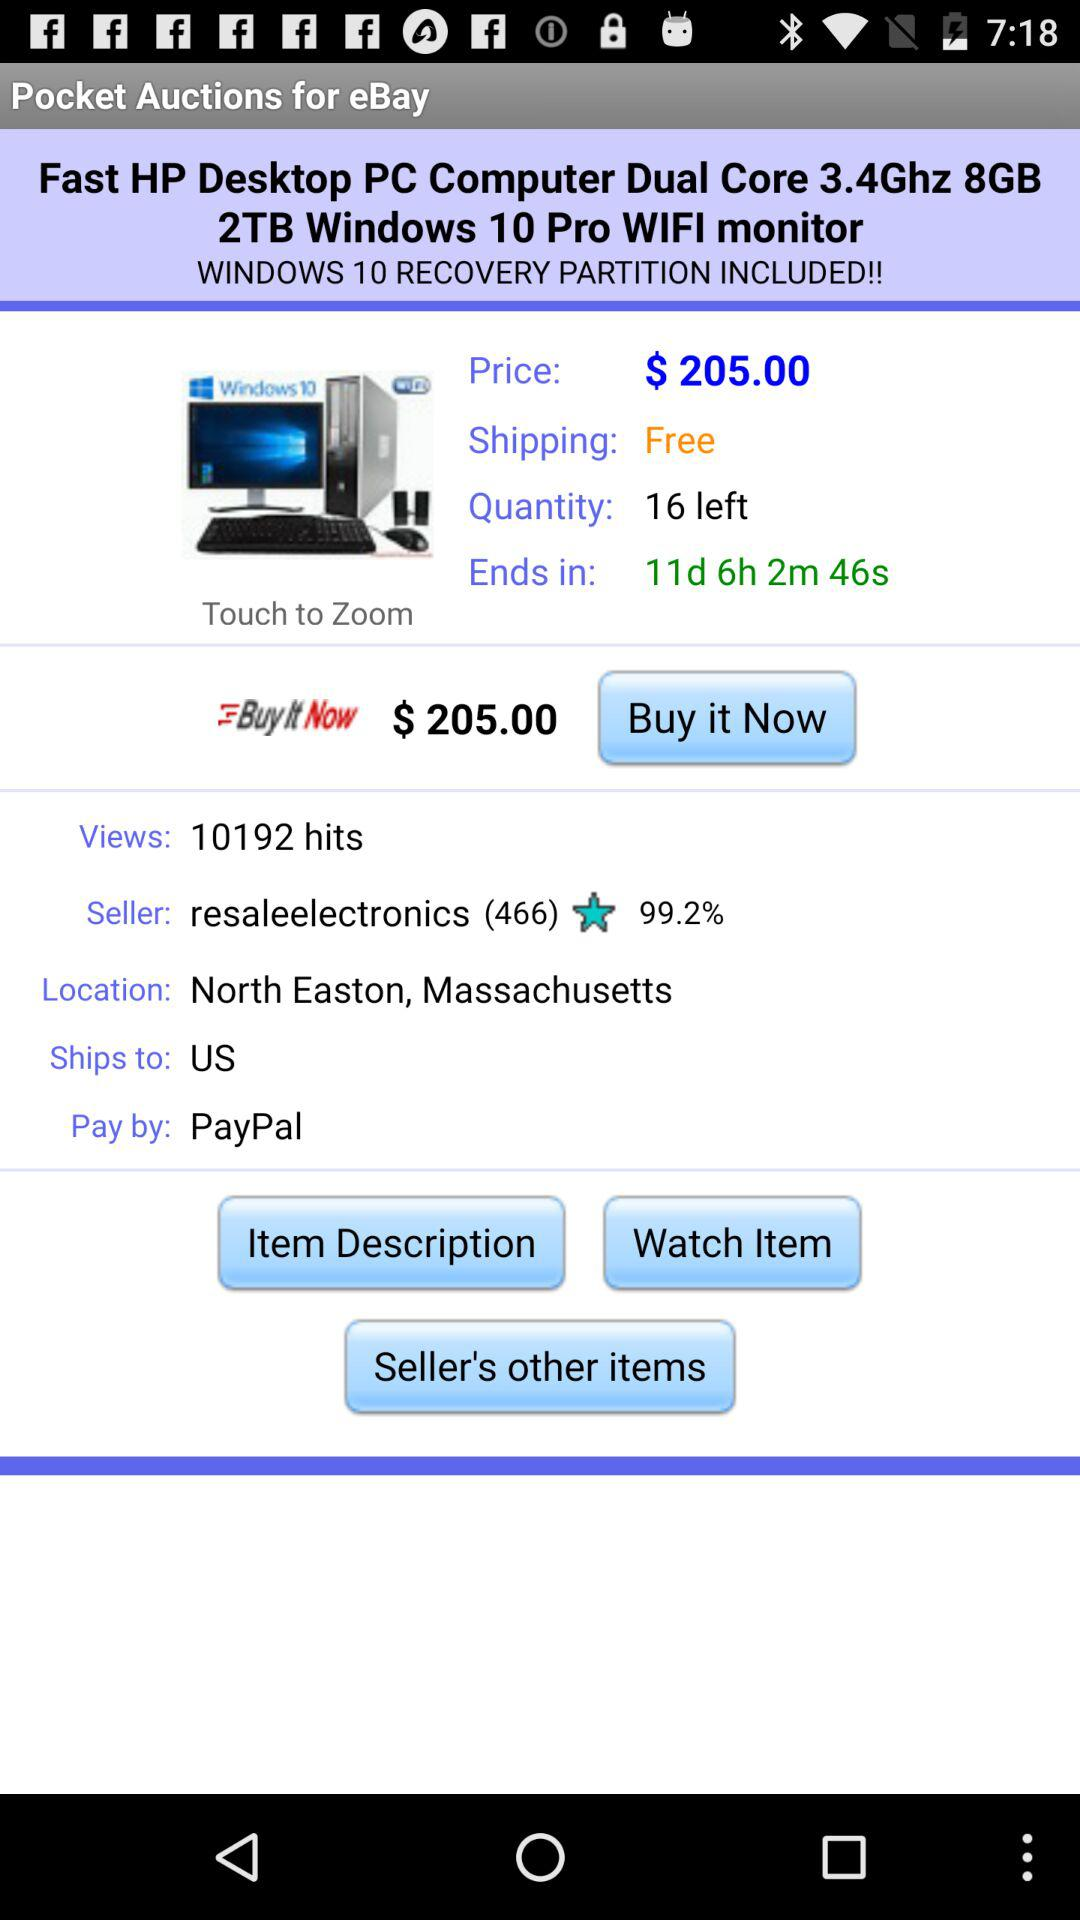What is the price? The price is $205. 